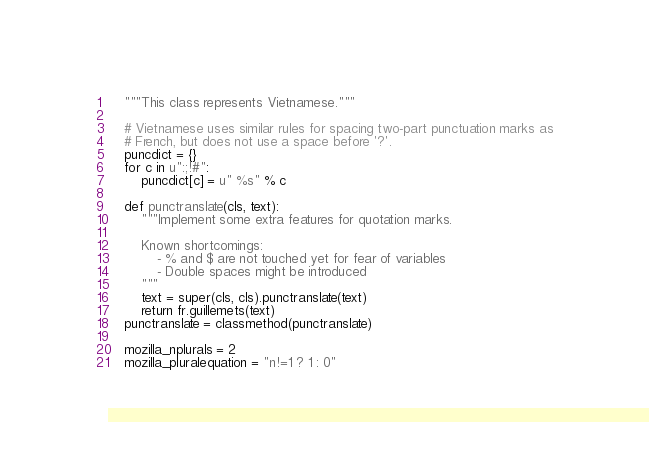Convert code to text. <code><loc_0><loc_0><loc_500><loc_500><_Python_>    """This class represents Vietnamese."""

    # Vietnamese uses similar rules for spacing two-part punctuation marks as
    # French, but does not use a space before '?'.
    puncdict = {}
    for c in u":;!#":
        puncdict[c] = u" %s" % c

    def punctranslate(cls, text):
        """Implement some extra features for quotation marks.

        Known shortcomings:
            - % and $ are not touched yet for fear of variables
            - Double spaces might be introduced
        """
        text = super(cls, cls).punctranslate(text)
        return fr.guillemets(text)
    punctranslate = classmethod(punctranslate)

    mozilla_nplurals = 2
    mozilla_pluralequation = "n!=1 ? 1 : 0"
</code> 